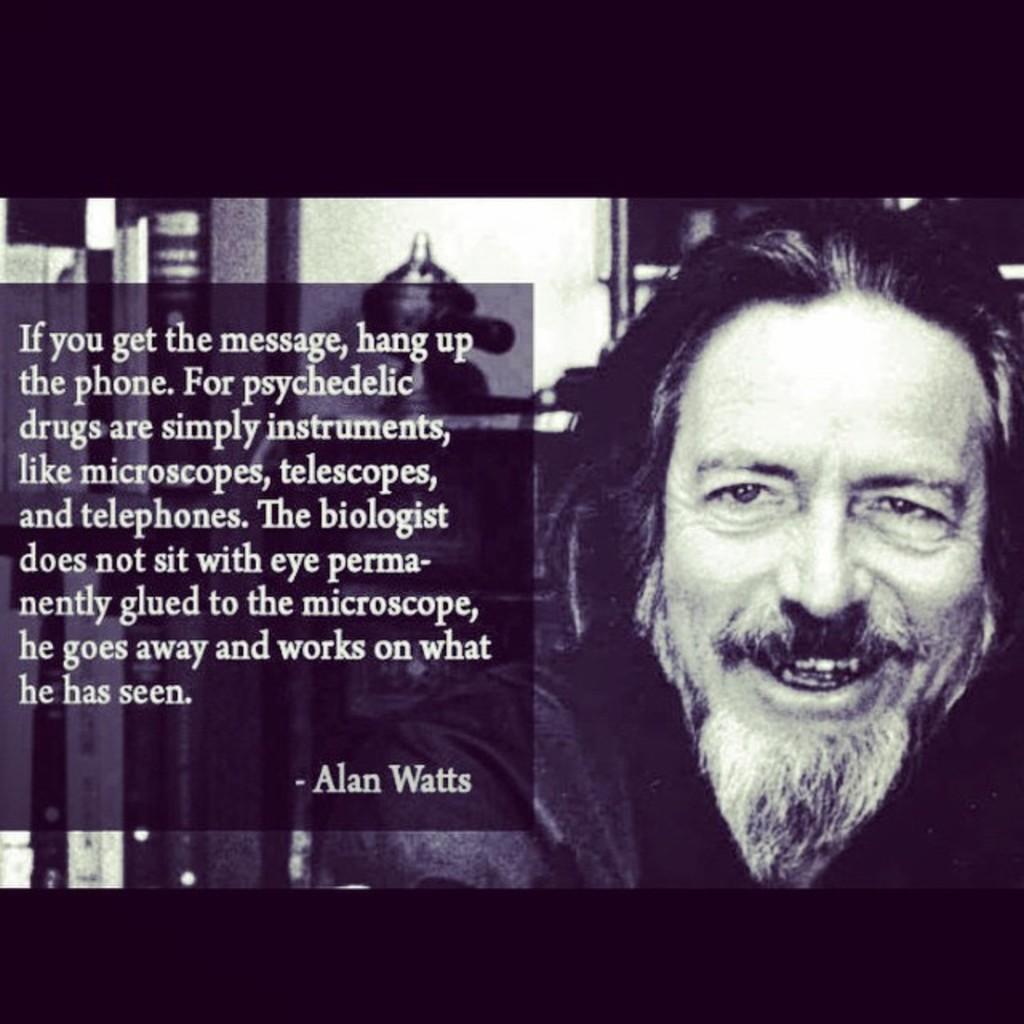How would you summarize this image in a sentence or two? This is an edited image we can see a person is smiling and behind the person there are some objects and on the image there is a quotation. 